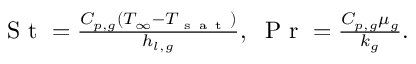<formula> <loc_0><loc_0><loc_500><loc_500>\begin{array} { r } { S t = \frac { C _ { p , g } ( T _ { \infty } - T _ { s a t } ) } { h _ { l , g } } , \, P r = \frac { C _ { p , g } \mu _ { g } } { k _ { g } } . } \end{array}</formula> 